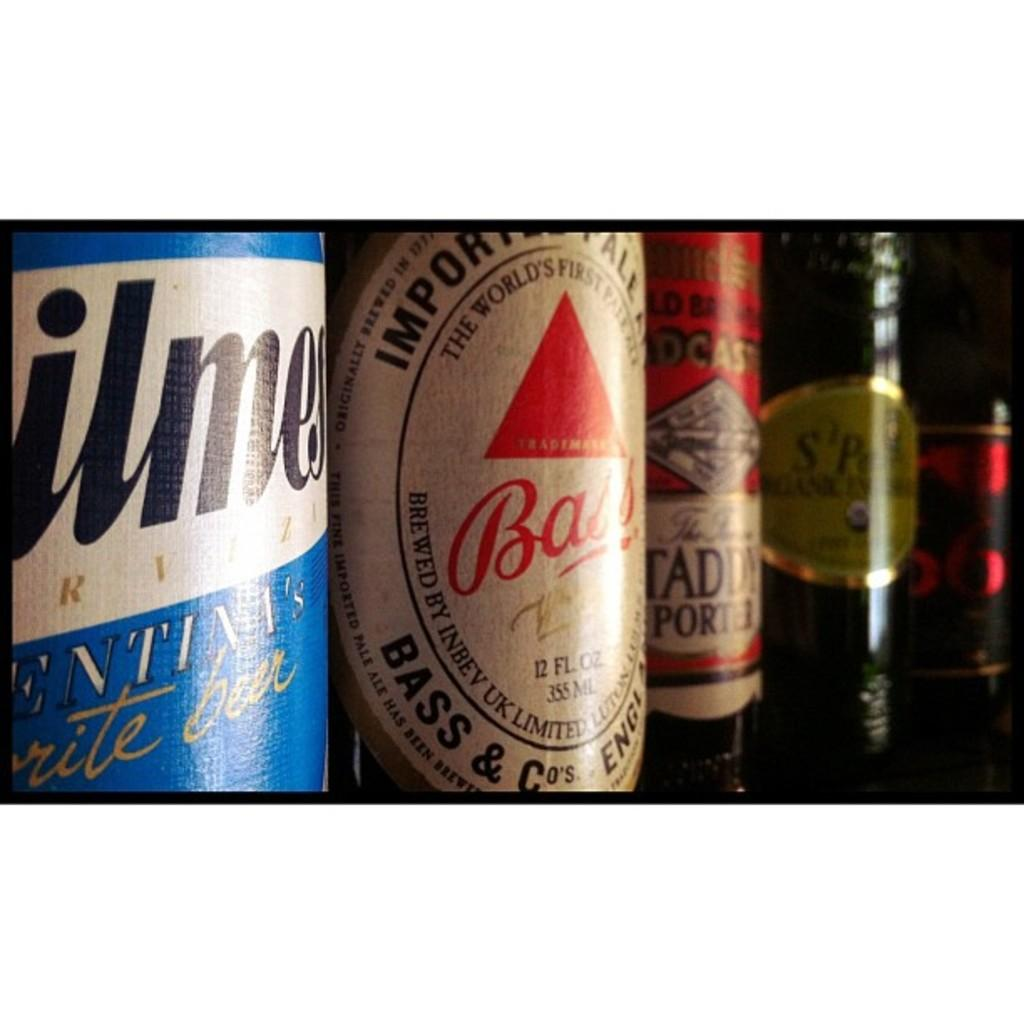<image>
Summarize the visual content of the image. A bottle of Bass beer is on a shelf with other beers. 